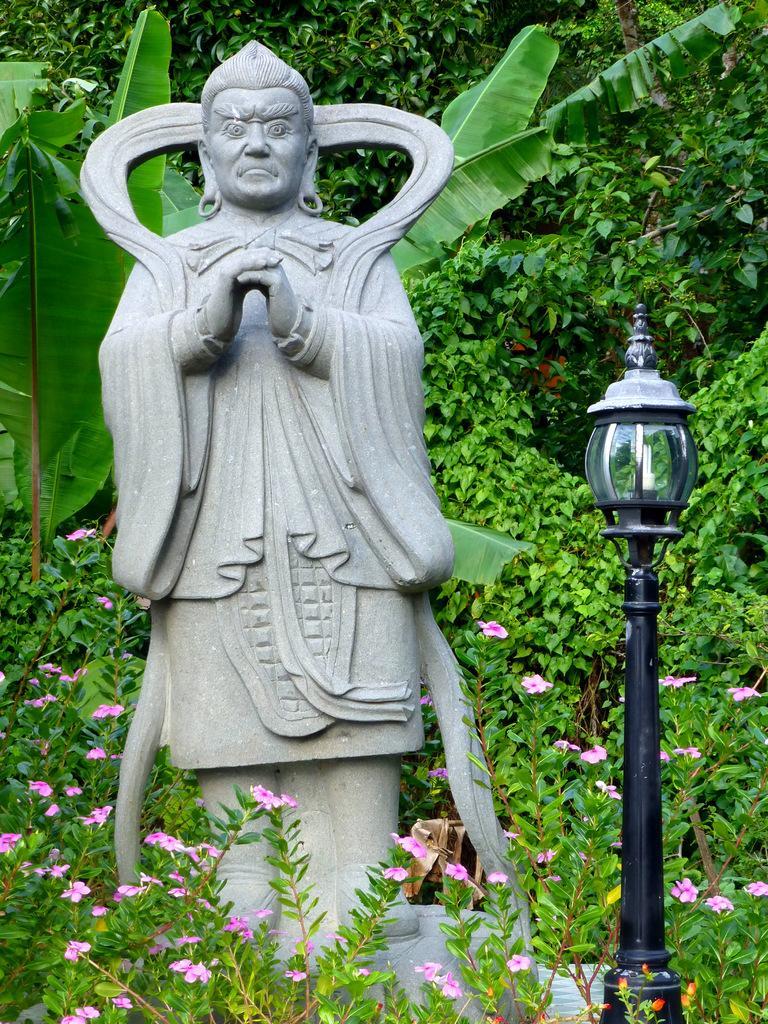In one or two sentences, can you explain what this image depicts? In this image we can see statue, light, trees, plants and flowers. 